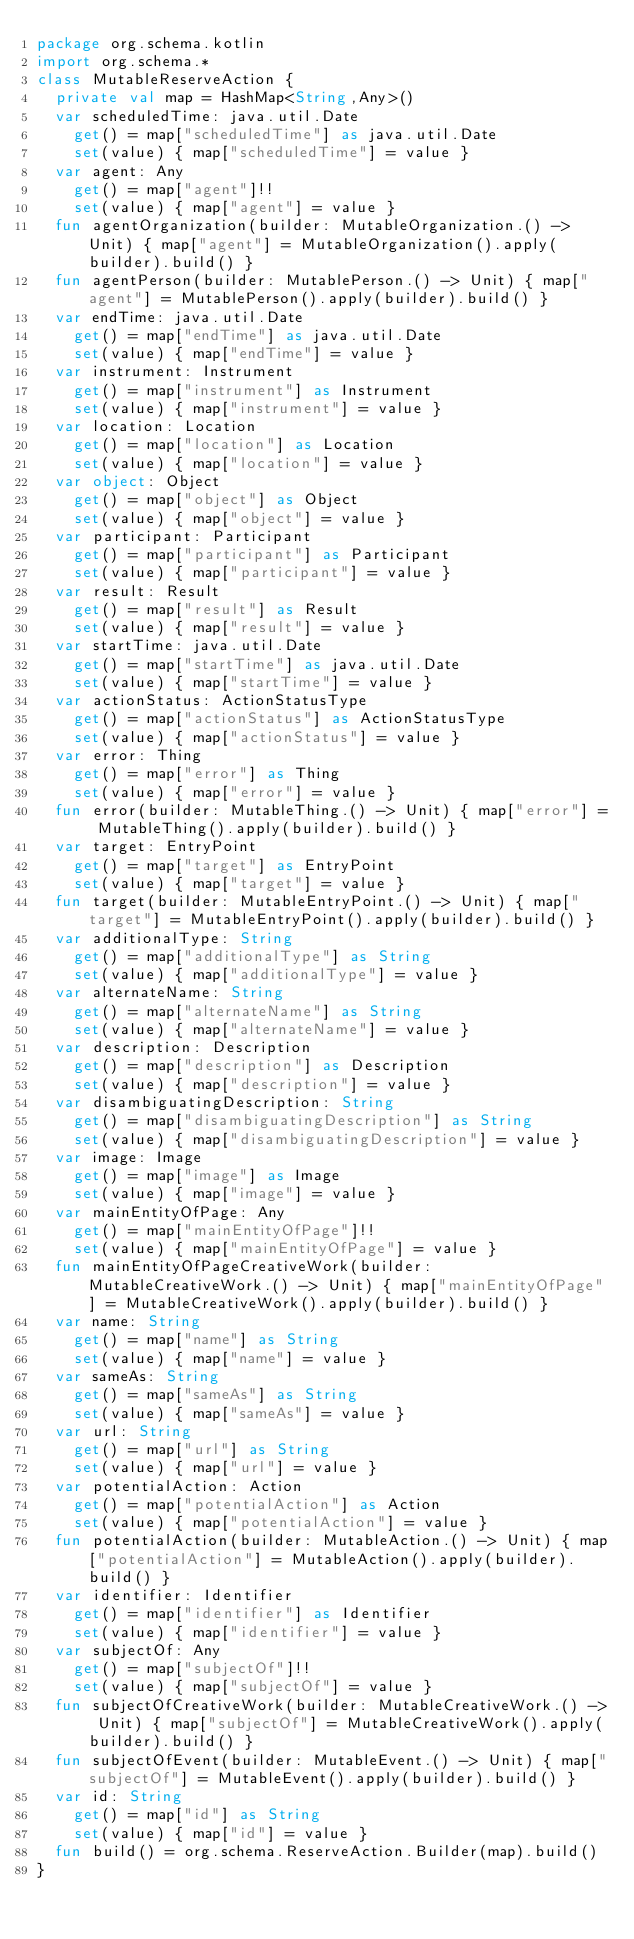<code> <loc_0><loc_0><loc_500><loc_500><_Kotlin_>package org.schema.kotlin
import org.schema.*
class MutableReserveAction {
  private val map = HashMap<String,Any>()
  var scheduledTime: java.util.Date
    get() = map["scheduledTime"] as java.util.Date
    set(value) { map["scheduledTime"] = value }
  var agent: Any
    get() = map["agent"]!!
    set(value) { map["agent"] = value }
  fun agentOrganization(builder: MutableOrganization.() -> Unit) { map["agent"] = MutableOrganization().apply(builder).build() }
  fun agentPerson(builder: MutablePerson.() -> Unit) { map["agent"] = MutablePerson().apply(builder).build() }
  var endTime: java.util.Date
    get() = map["endTime"] as java.util.Date
    set(value) { map["endTime"] = value }
  var instrument: Instrument
    get() = map["instrument"] as Instrument
    set(value) { map["instrument"] = value }
  var location: Location
    get() = map["location"] as Location
    set(value) { map["location"] = value }
  var object: Object
    get() = map["object"] as Object
    set(value) { map["object"] = value }
  var participant: Participant
    get() = map["participant"] as Participant
    set(value) { map["participant"] = value }
  var result: Result
    get() = map["result"] as Result
    set(value) { map["result"] = value }
  var startTime: java.util.Date
    get() = map["startTime"] as java.util.Date
    set(value) { map["startTime"] = value }
  var actionStatus: ActionStatusType
    get() = map["actionStatus"] as ActionStatusType
    set(value) { map["actionStatus"] = value }
  var error: Thing
    get() = map["error"] as Thing
    set(value) { map["error"] = value }
  fun error(builder: MutableThing.() -> Unit) { map["error"] = MutableThing().apply(builder).build() }
  var target: EntryPoint
    get() = map["target"] as EntryPoint
    set(value) { map["target"] = value }
  fun target(builder: MutableEntryPoint.() -> Unit) { map["target"] = MutableEntryPoint().apply(builder).build() }
  var additionalType: String
    get() = map["additionalType"] as String
    set(value) { map["additionalType"] = value }
  var alternateName: String
    get() = map["alternateName"] as String
    set(value) { map["alternateName"] = value }
  var description: Description
    get() = map["description"] as Description
    set(value) { map["description"] = value }
  var disambiguatingDescription: String
    get() = map["disambiguatingDescription"] as String
    set(value) { map["disambiguatingDescription"] = value }
  var image: Image
    get() = map["image"] as Image
    set(value) { map["image"] = value }
  var mainEntityOfPage: Any
    get() = map["mainEntityOfPage"]!!
    set(value) { map["mainEntityOfPage"] = value }
  fun mainEntityOfPageCreativeWork(builder: MutableCreativeWork.() -> Unit) { map["mainEntityOfPage"] = MutableCreativeWork().apply(builder).build() }
  var name: String
    get() = map["name"] as String
    set(value) { map["name"] = value }
  var sameAs: String
    get() = map["sameAs"] as String
    set(value) { map["sameAs"] = value }
  var url: String
    get() = map["url"] as String
    set(value) { map["url"] = value }
  var potentialAction: Action
    get() = map["potentialAction"] as Action
    set(value) { map["potentialAction"] = value }
  fun potentialAction(builder: MutableAction.() -> Unit) { map["potentialAction"] = MutableAction().apply(builder).build() }
  var identifier: Identifier
    get() = map["identifier"] as Identifier
    set(value) { map["identifier"] = value }
  var subjectOf: Any
    get() = map["subjectOf"]!!
    set(value) { map["subjectOf"] = value }
  fun subjectOfCreativeWork(builder: MutableCreativeWork.() -> Unit) { map["subjectOf"] = MutableCreativeWork().apply(builder).build() }
  fun subjectOfEvent(builder: MutableEvent.() -> Unit) { map["subjectOf"] = MutableEvent().apply(builder).build() }
  var id: String
    get() = map["id"] as String
    set(value) { map["id"] = value }
  fun build() = org.schema.ReserveAction.Builder(map).build()
}
</code> 